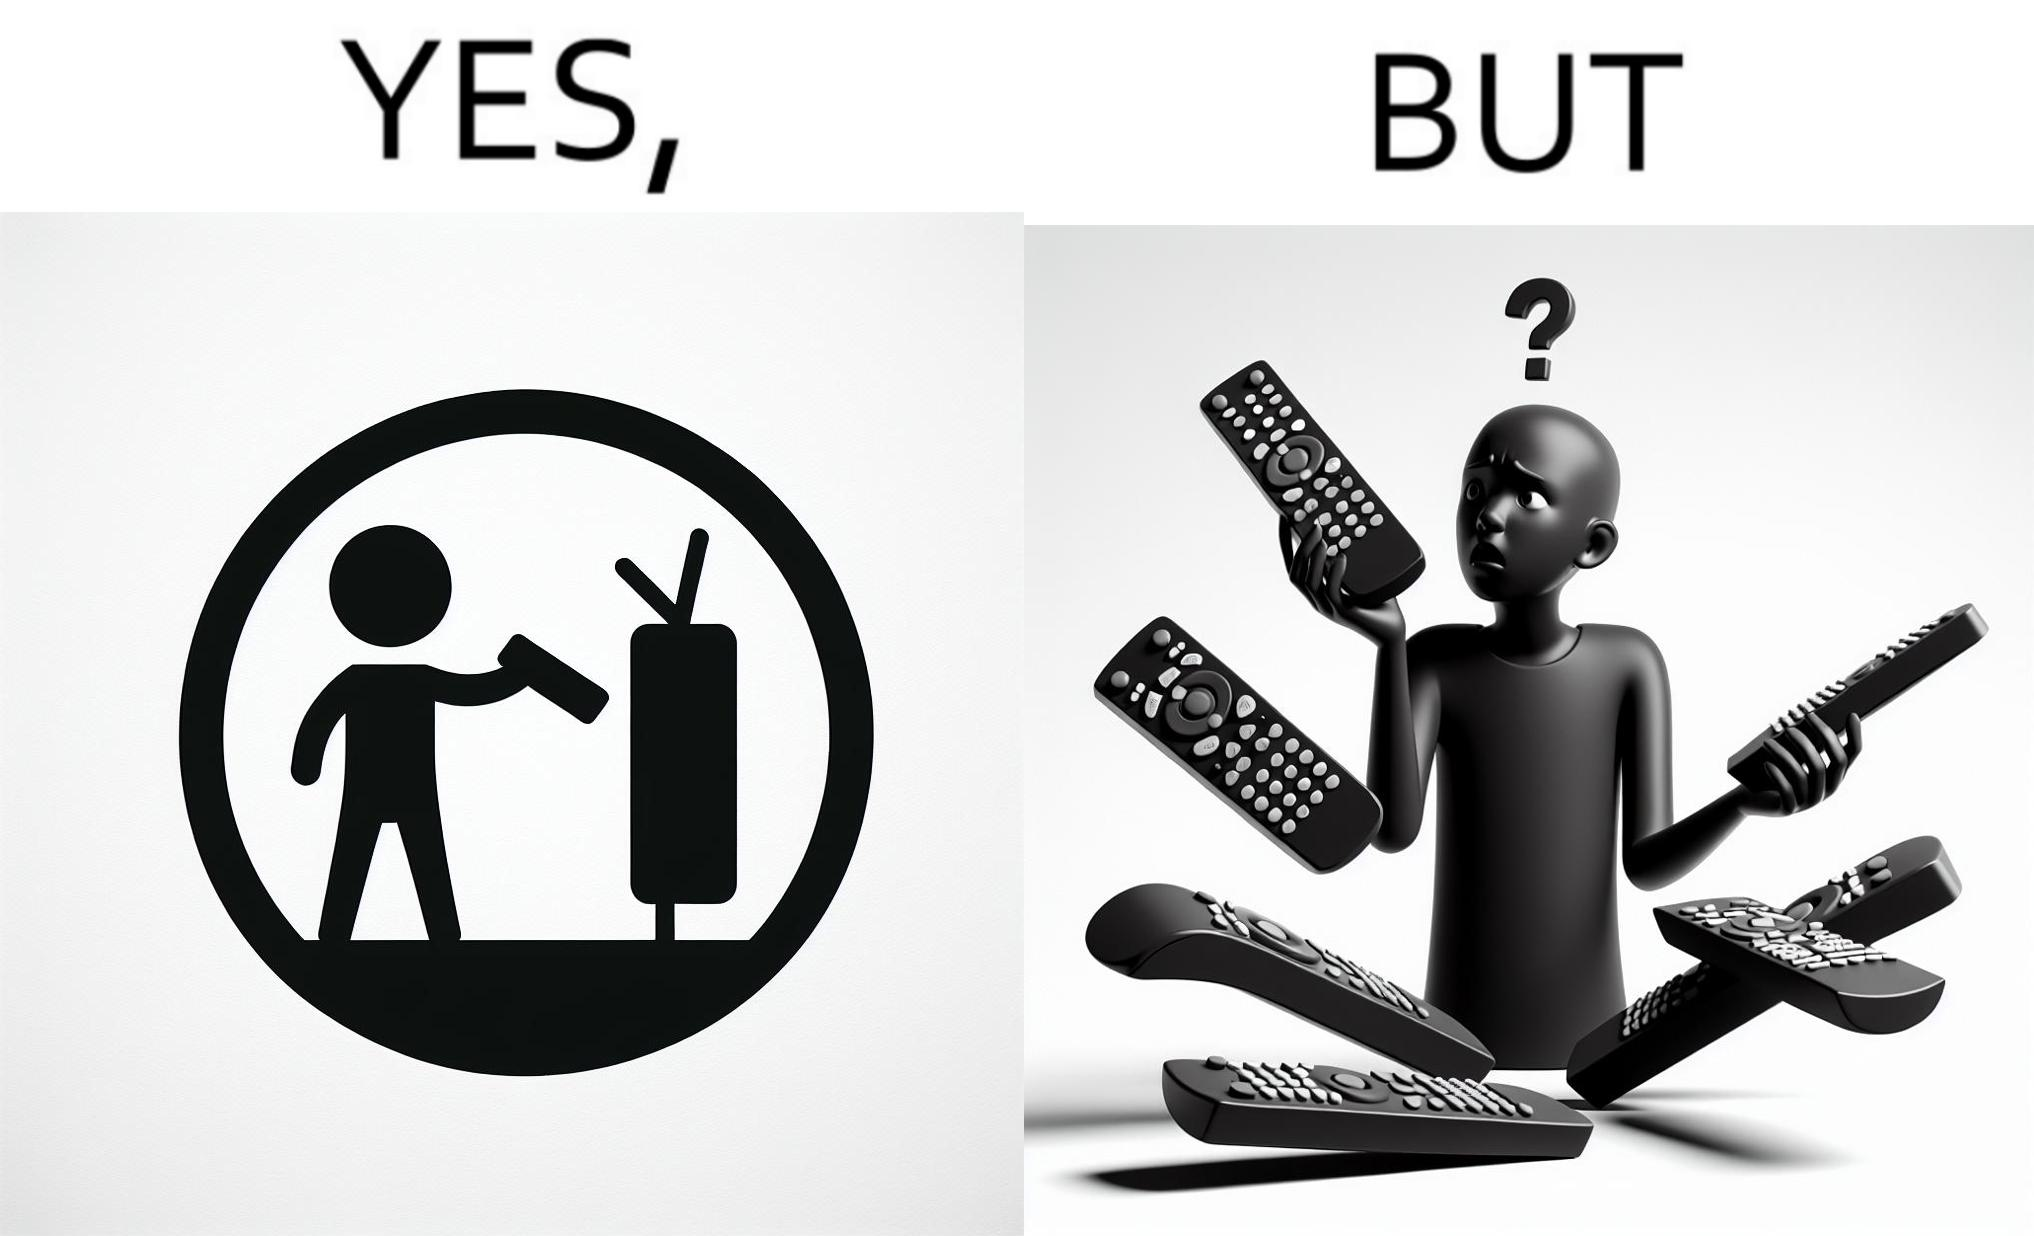Provide a description of this image. The images are funny since they show how even though TV remotes are supposed to make operating TVs easier, having multiple similar looking remotes  for everything only makes it more difficult for the user to use the right one 